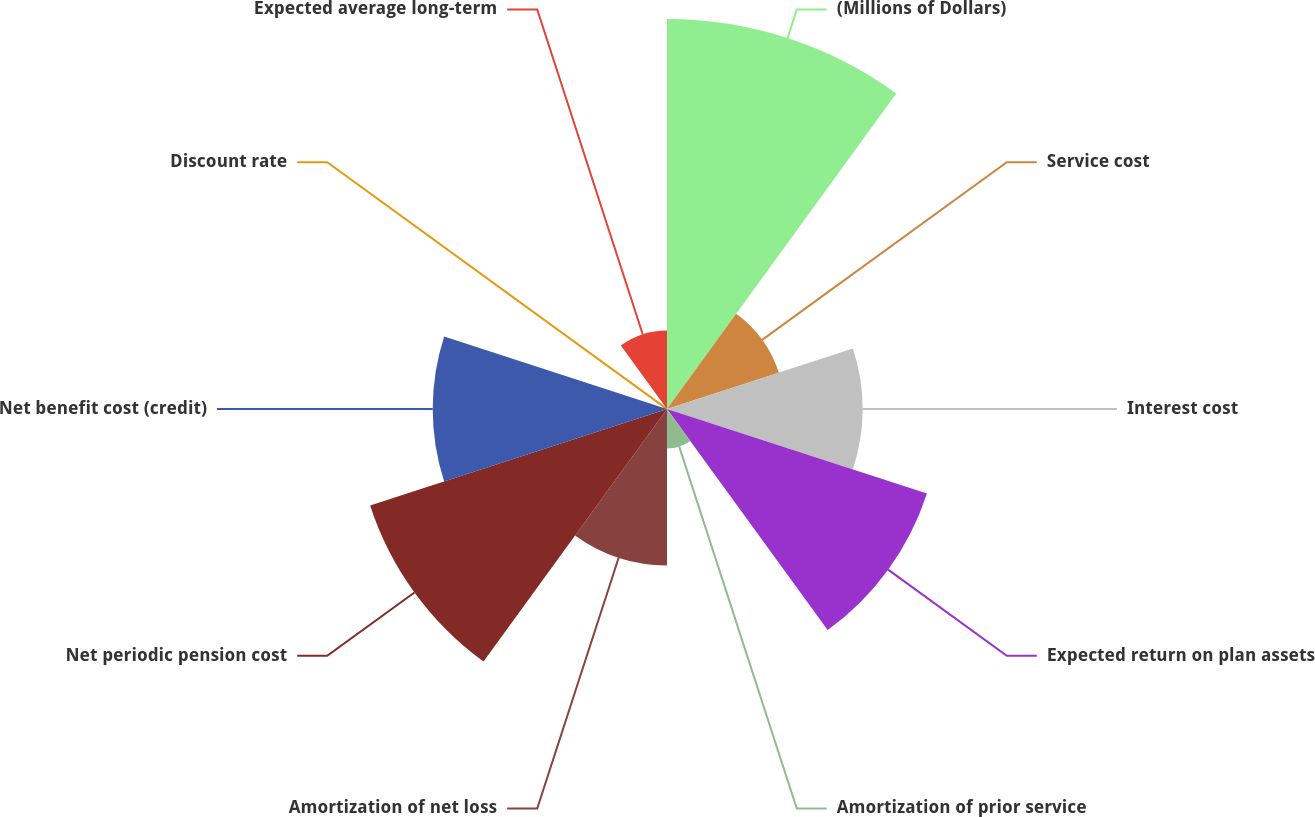Convert chart to OTSL. <chart><loc_0><loc_0><loc_500><loc_500><pie_chart><fcel>(Millions of Dollars)<fcel>Service cost<fcel>Interest cost<fcel>Expected return on plan assets<fcel>Amortization of prior service<fcel>Amortization of net loss<fcel>Net periodic pension cost<fcel>Net benefit cost (credit)<fcel>Discount rate<fcel>Expected average long-term<nl><fcel>21.69%<fcel>6.54%<fcel>10.87%<fcel>15.2%<fcel>2.2%<fcel>8.7%<fcel>17.36%<fcel>13.03%<fcel>0.04%<fcel>4.37%<nl></chart> 